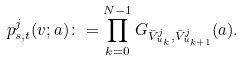<formula> <loc_0><loc_0><loc_500><loc_500>p _ { s , t } ^ { j } ( v ; a ) \colon = \prod _ { k = 0 } ^ { N - 1 } G _ { \bar { V } _ { u _ { k } } ^ { j } , \bar { V } _ { u _ { k + 1 } } ^ { j } } ( a ) .</formula> 